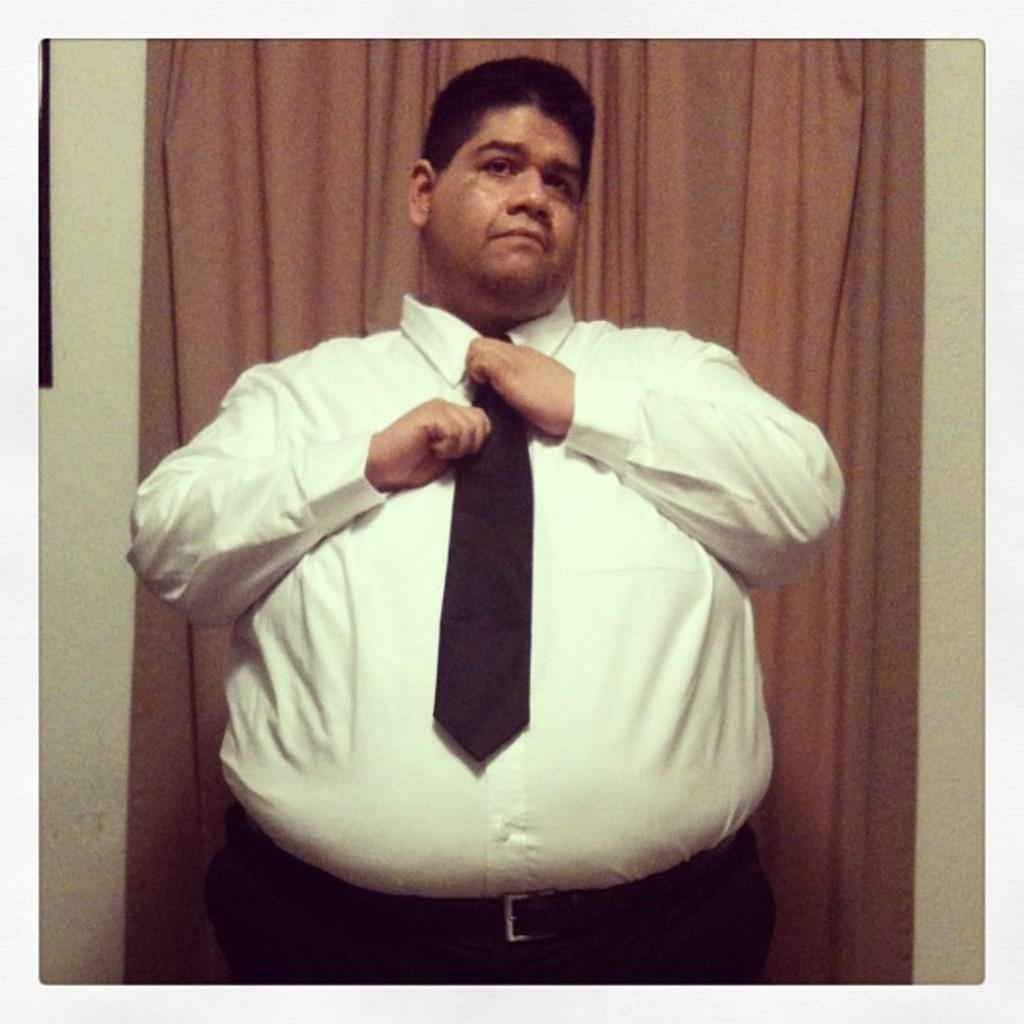What is the person in the image doing? The person is tying a tie. What can be seen behind the person? There is a wall behind the person. Are there any other objects or features in the image? Yes, there is a curtain in the image. What type of spoon is being used to adjust the light in the image? There is no spoon or light present in the image; it only features a person tying a tie and a curtain. 